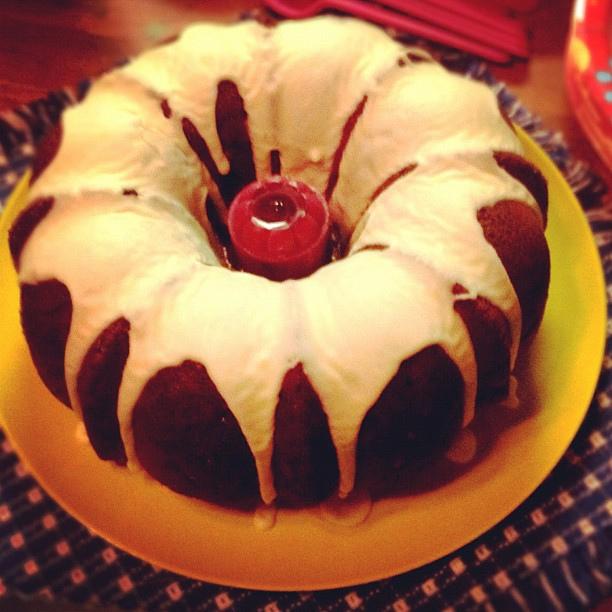What kind of cake is that?
Write a very short answer. Bundt cake. What color is the plate?
Write a very short answer. Yellow. What is in the middle of the plate?
Give a very brief answer. Candle. Is this a cake?
Write a very short answer. Yes. What kind of cake is this?
Be succinct. Bundt. What is the cake for?
Keep it brief. Dessert. 